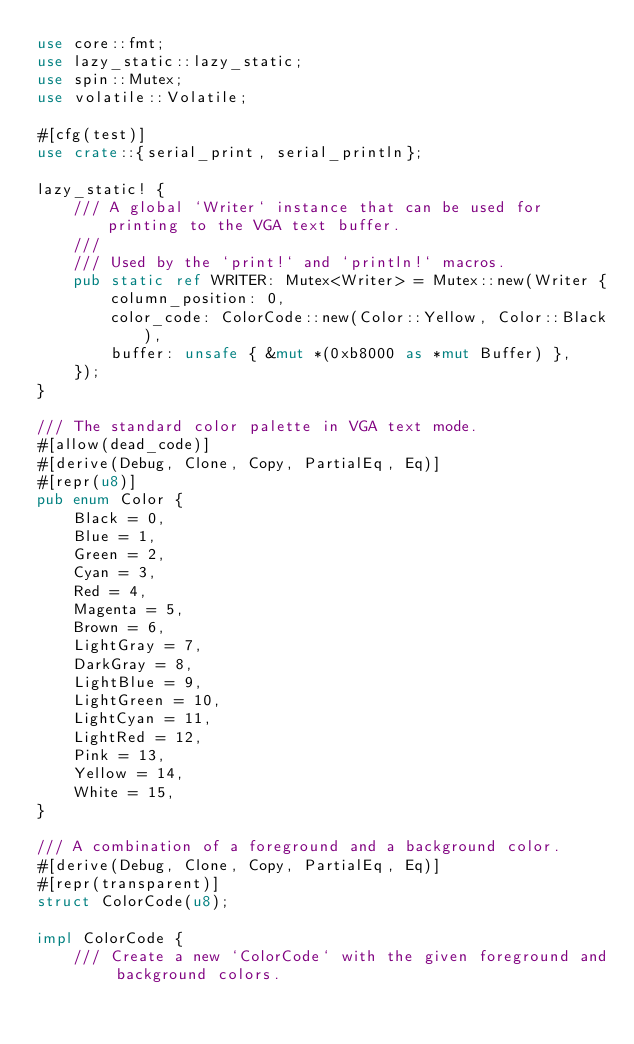<code> <loc_0><loc_0><loc_500><loc_500><_Rust_>use core::fmt;
use lazy_static::lazy_static;
use spin::Mutex;
use volatile::Volatile;

#[cfg(test)]
use crate::{serial_print, serial_println};

lazy_static! {
    /// A global `Writer` instance that can be used for printing to the VGA text buffer.
    ///
    /// Used by the `print!` and `println!` macros.
    pub static ref WRITER: Mutex<Writer> = Mutex::new(Writer {
        column_position: 0,
        color_code: ColorCode::new(Color::Yellow, Color::Black),
        buffer: unsafe { &mut *(0xb8000 as *mut Buffer) },
    });
}

/// The standard color palette in VGA text mode.
#[allow(dead_code)]
#[derive(Debug, Clone, Copy, PartialEq, Eq)]
#[repr(u8)]
pub enum Color {
    Black = 0,
    Blue = 1,
    Green = 2,
    Cyan = 3,
    Red = 4,
    Magenta = 5,
    Brown = 6,
    LightGray = 7,
    DarkGray = 8,
    LightBlue = 9,
    LightGreen = 10,
    LightCyan = 11,
    LightRed = 12,
    Pink = 13,
    Yellow = 14,
    White = 15,
}

/// A combination of a foreground and a background color.
#[derive(Debug, Clone, Copy, PartialEq, Eq)]
#[repr(transparent)]
struct ColorCode(u8);

impl ColorCode {
    /// Create a new `ColorCode` with the given foreground and background colors.</code> 